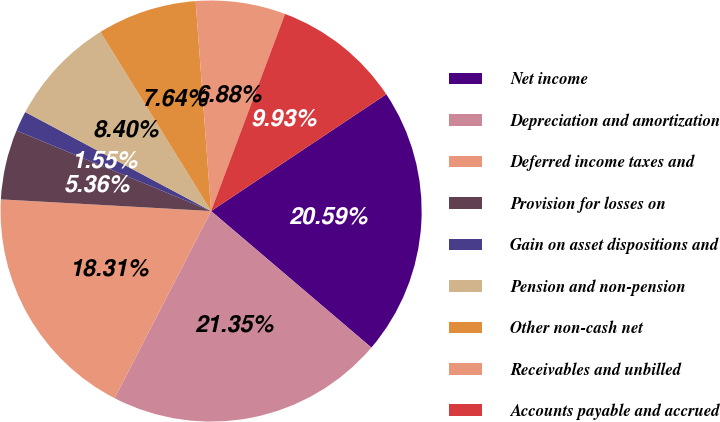<chart> <loc_0><loc_0><loc_500><loc_500><pie_chart><fcel>Net income<fcel>Depreciation and amortization<fcel>Deferred income taxes and<fcel>Provision for losses on<fcel>Gain on asset dispositions and<fcel>Pension and non-pension<fcel>Other non-cash net<fcel>Receivables and unbilled<fcel>Accounts payable and accrued<nl><fcel>20.59%<fcel>21.35%<fcel>18.31%<fcel>5.36%<fcel>1.55%<fcel>8.4%<fcel>7.64%<fcel>6.88%<fcel>9.93%<nl></chart> 